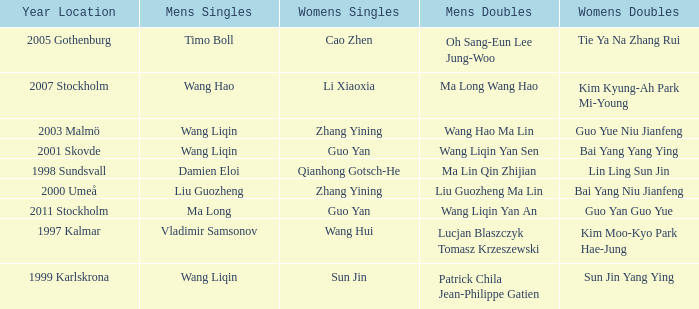How many times has Sun Jin won the women's doubles? 1.0. 